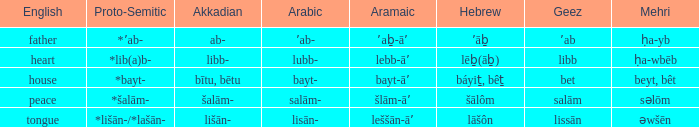Would you be able to parse every entry in this table? {'header': ['English', 'Proto-Semitic', 'Akkadian', 'Arabic', 'Aramaic', 'Hebrew', 'Geez', 'Mehri'], 'rows': [['father', '*ʼab-', 'ab-', 'ʼab-', 'ʼaḇ-āʼ', 'ʼāḇ', 'ʼab', 'ḥa-yb'], ['heart', '*lib(a)b-', 'libb-', 'lubb-', 'lebb-āʼ', 'lēḇ(āḇ)', 'libb', 'ḥa-wbēb'], ['house', '*bayt-', 'bītu, bētu', 'bayt-', 'bayt-āʼ', 'báyiṯ, bêṯ', 'bet', 'beyt, bêt'], ['peace', '*šalām-', 'šalām-', 'salām-', 'šlām-āʼ', 'šālôm', 'salām', 'səlōm'], ['tongue', '*lišān-/*lašān-', 'lišān-', 'lisān-', 'leššān-āʼ', 'lāšôn', 'lissān', 'əwšēn']]} If in English it's house, what is it in proto-semitic? *bayt-. 